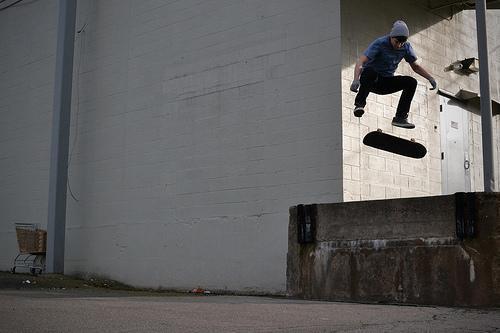How many people are there?
Give a very brief answer. 1. 